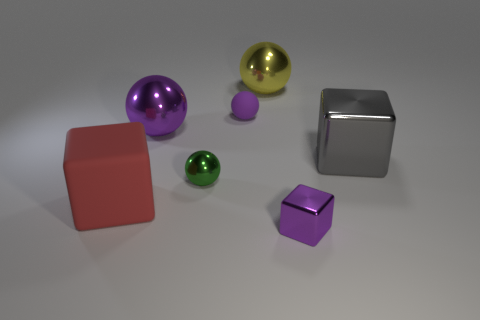The yellow thing that is the same material as the green sphere is what shape?
Your response must be concise. Sphere. Is the number of big blocks less than the number of big red blocks?
Keep it short and to the point. No. What material is the tiny object that is left of the small purple metallic cube and in front of the big gray shiny block?
Give a very brief answer. Metal. What is the size of the rubber thing that is behind the metallic object that is on the left side of the tiny sphere that is in front of the big gray cube?
Your answer should be very brief. Small. There is a large red matte thing; does it have the same shape as the metal object that is right of the small purple metal block?
Your answer should be compact. Yes. What number of things are on the left side of the small green object and right of the rubber block?
Your answer should be very brief. 1. How many brown things are small metal things or tiny metallic balls?
Keep it short and to the point. 0. There is a sphere that is on the right side of the matte sphere; is it the same color as the large block left of the large yellow metal ball?
Your answer should be compact. No. There is a tiny metal thing behind the matte block in front of the big shiny ball that is behind the small rubber thing; what color is it?
Offer a very short reply. Green. Is there a sphere in front of the rubber object that is in front of the rubber sphere?
Your response must be concise. No. 